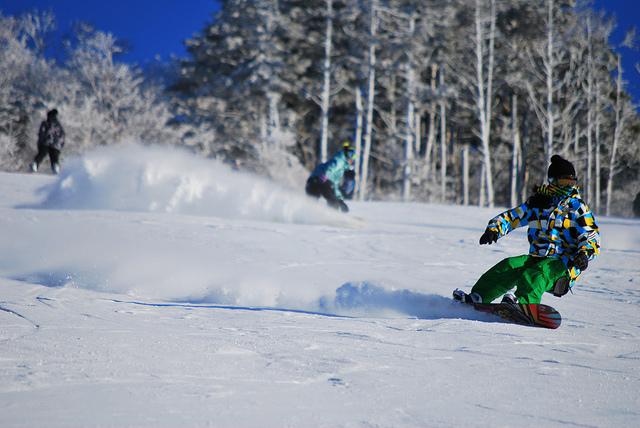Would you feel safe here?
Concise answer only. No. How many people are seen  in the photo?
Write a very short answer. 3. Is this boy good at snowboarding?
Keep it brief. Yes. Is the snowboard flat on its bottom edge?
Keep it brief. No. How far off the ground is the snowboarder?
Keep it brief. On ground. 